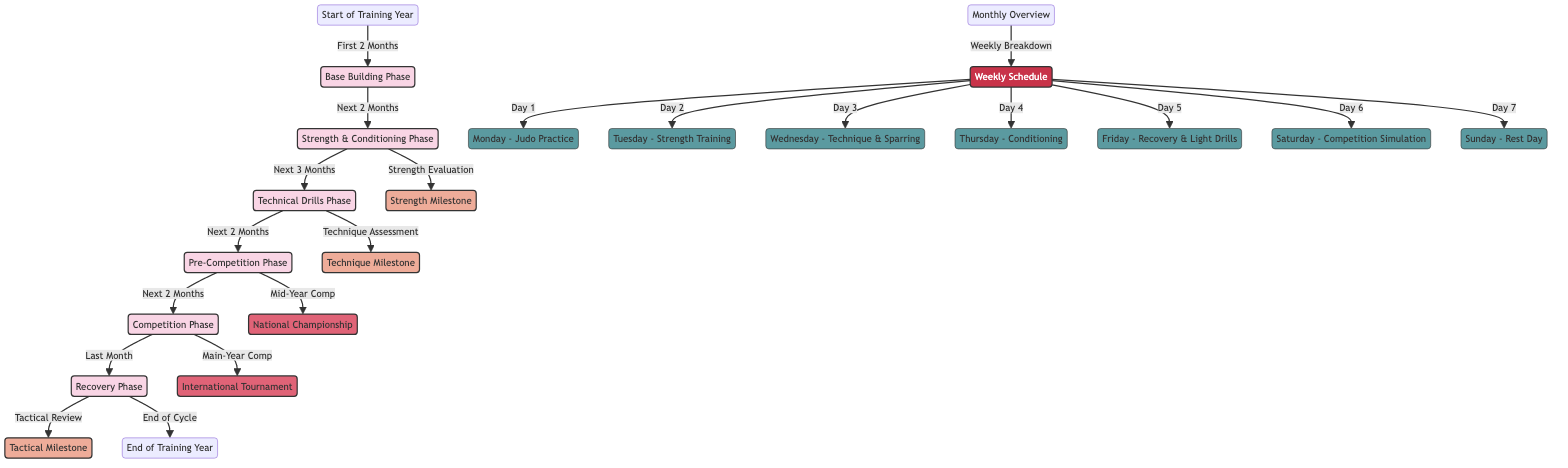What is the first phase of the training schedule? The diagram shows that the first phase of the training schedule is labeled as "Base Building Phase." This is the starting point after the "Start of Training Year" node.
Answer: Base Building Phase How long does the Strength & Conditioning Phase last? According to the diagram, it follows the "Base Building Phase" and consists of "Next 2 Months." This means the duration of this phase is two months.
Answer: 2 Months What is scheduled for Monday during the weekly schedule? The diagram clearly indicates that Monday is designated for "Judo Practice," making it straightforward to identify the activity for that day.
Answer: Judo Practice Which milestone is associated with the Technique Assessment? The diagram connects "Technique Assessment" to a milestone labeled "Technique Milestone." Following the flow, this confirms the association.
Answer: Technique Milestone What are the major competitions listed in the training schedule? By reviewing the nodes in the diagram related to competition, we can see two labeled nodes: "National Championship" and "International Tournament." These are the competitions specified in the schedule.
Answer: National Championship, International Tournament What is the final phase before the end of the training year? The diagram indicates that the last phase before concluding the training year is the "Recovery Phase," which follows the "Competition Phase."
Answer: Recovery Phase How many rest days are included in the weekly schedule? By analyzing the weekly schedule in the diagram, there is one designated rest day: "Sunday - Rest Day." Thus, the total number of rest days is one.
Answer: 1 How is the Tactical Review phase linked to competitions? The "Tactical Review" phase is linked to the "End of Cycle" milestone; although it does not directly connect to a competition, it is the assessment following competition phases, indicating its role in improving techniques for competitions.
Answer: Tactical Review How does the training schedule categorize the week? The training schedule categorizes the week with specific activities assigned to each day, indicating a structured and planned approach consisting of six training activities and one rest day.
Answer: 7 Days (6 activities, 1 rest day) 